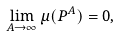<formula> <loc_0><loc_0><loc_500><loc_500>\lim _ { A \to \infty } \mu ( P ^ { A } ) = 0 ,</formula> 